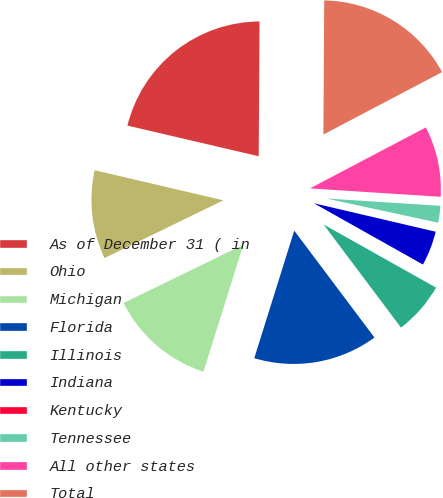<chart> <loc_0><loc_0><loc_500><loc_500><pie_chart><fcel>As of December 31 ( in<fcel>Ohio<fcel>Michigan<fcel>Florida<fcel>Illinois<fcel>Indiana<fcel>Kentucky<fcel>Tennessee<fcel>All other states<fcel>Total<nl><fcel>21.44%<fcel>10.85%<fcel>12.97%<fcel>15.08%<fcel>6.61%<fcel>4.49%<fcel>0.26%<fcel>2.37%<fcel>8.73%<fcel>17.2%<nl></chart> 